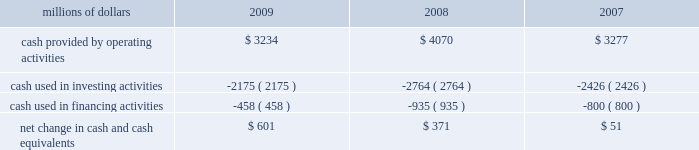Have access to liquidity by issuing bonds to public or private investors based on our assessment of the current condition of the credit markets .
At december 31 , 2009 , we had a working capital surplus of approximately $ 1.0 billion , which reflects our decision to maintain additional cash reserves to enhance liquidity in response to difficult economic conditions .
At december 31 , 2008 , we had a working capital deficit of approximately $ 100 million .
Historically , we have had a working capital deficit , which is common in our industry and does not indicate a lack of liquidity .
We maintain adequate resources and , when necessary , have access to capital to meet any daily and short-term cash requirements , and we have sufficient financial capacity to satisfy our current liabilities .
Cash flows millions of dollars 2009 2008 2007 .
Operating activities lower net income in 2009 , a reduction of $ 184 million in the outstanding balance of our accounts receivable securitization program , higher pension contributions of $ 72 million , and changes to working capital combined to decrease cash provided by operating activities compared to 2008 .
Higher net income and changes in working capital combined to increase cash provided by operating activities in 2008 compared to 2007 .
In addition , accelerated tax deductions enacted in 2008 on certain new operating assets resulted in lower income tax payments in 2008 versus 2007 .
Voluntary pension contributions in 2008 totaling $ 200 million and other pension contributions of $ 8 million partially offset the year-over-year increase versus 2007 .
Investing activities lower capital investments and higher proceeds from asset sales drove the decrease in cash used in investing activities in 2009 versus 2008 .
Increased capital investments and lower proceeds from asset sales drove the increase in cash used in investing activities in 2008 compared to 2007. .
What was the net working capital surplus for 2008 and 2009 , in millions? 
Computations: ((1 * 1000) - 100)
Answer: 900.0. Have access to liquidity by issuing bonds to public or private investors based on our assessment of the current condition of the credit markets .
At december 31 , 2009 , we had a working capital surplus of approximately $ 1.0 billion , which reflects our decision to maintain additional cash reserves to enhance liquidity in response to difficult economic conditions .
At december 31 , 2008 , we had a working capital deficit of approximately $ 100 million .
Historically , we have had a working capital deficit , which is common in our industry and does not indicate a lack of liquidity .
We maintain adequate resources and , when necessary , have access to capital to meet any daily and short-term cash requirements , and we have sufficient financial capacity to satisfy our current liabilities .
Cash flows millions of dollars 2009 2008 2007 .
Operating activities lower net income in 2009 , a reduction of $ 184 million in the outstanding balance of our accounts receivable securitization program , higher pension contributions of $ 72 million , and changes to working capital combined to decrease cash provided by operating activities compared to 2008 .
Higher net income and changes in working capital combined to increase cash provided by operating activities in 2008 compared to 2007 .
In addition , accelerated tax deductions enacted in 2008 on certain new operating assets resulted in lower income tax payments in 2008 versus 2007 .
Voluntary pension contributions in 2008 totaling $ 200 million and other pension contributions of $ 8 million partially offset the year-over-year increase versus 2007 .
Investing activities lower capital investments and higher proceeds from asset sales drove the decrease in cash used in investing activities in 2009 versus 2008 .
Increased capital investments and lower proceeds from asset sales drove the increase in cash used in investing activities in 2008 compared to 2007. .
Without the 2008 voluntary pension contributions , how much cash would have been provided by operating activities , in millions? 
Computations: (4070 + 200)
Answer: 4270.0. 